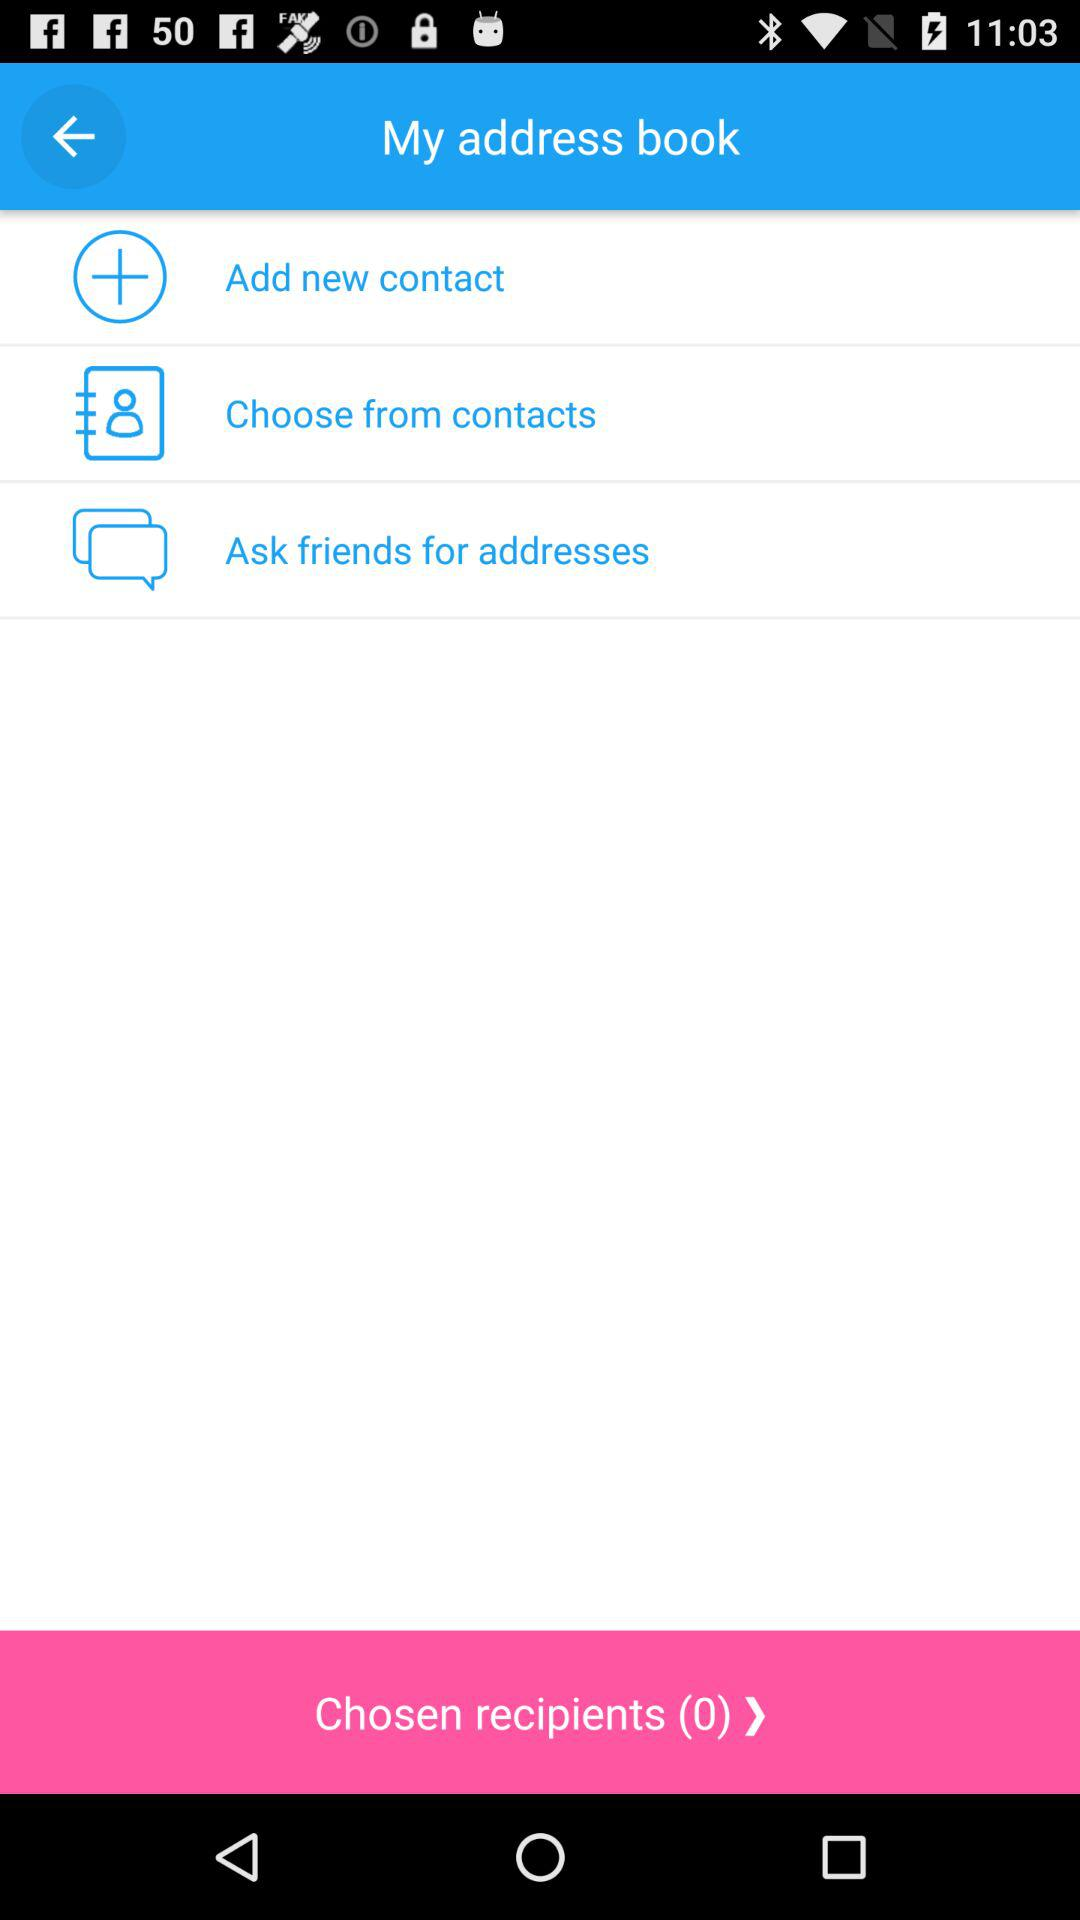What is the number of the chosen recipient? The number of the chosen recipient is zero. 